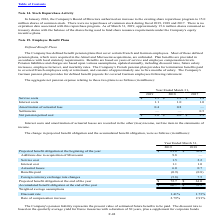According to Microchip Technology's financial document, What were plan benefits provided in accordance with? local statutory requirements. The document states: "ed. Plan benefits are provided in accordance with local statutory requirements. Benefits are based on years of service and employee compensation level..." Also, What were the service costs in 2018? According to the financial document, 2.2 (in millions). The relevant text states: "Service costs $ 1.5 $ 2.2 $ 1.4..." Also, What were the interest costs in 2017? According to the financial document, 1.0 (in millions). The relevant text states: "Interest costs 1.1 1.0 1.0..." Also, can you calculate: What was the change in service costs between 2017 and 2018? Based on the calculation: 2.2-1.4, the result is 0.8 (in millions). This is based on the information: "Service costs $ 1.5 $ 2.2 $ 1.4 Service costs $ 1.5 $ 2.2 $ 1.4..." The key data points involved are: 1.4, 2.2. Also, can you calculate: What was the change in the Amortization of actuarial loss between 2018 and 2019? Based on the calculation: 0.4-0.8, the result is -0.4 (in millions). This is based on the information: "Amortization of actuarial loss 0.4 0.8 — Amortization of actuarial loss 0.4 0.8 —..." The key data points involved are: 0.8. Also, can you calculate: What was the percentage change in the net pension period cost between 2018 and 2019? To answer this question, I need to perform calculations using the financial data. The calculation is: (3.0-4.0)/4.0, which equals -25 (percentage). This is based on the information: "Net pension period cost $ 3.0 $ 4.0 $ 2.9 Net pension period cost $ 3.0 $ 4.0 $ 2.9..." The key data points involved are: 3.0, 4.0. 